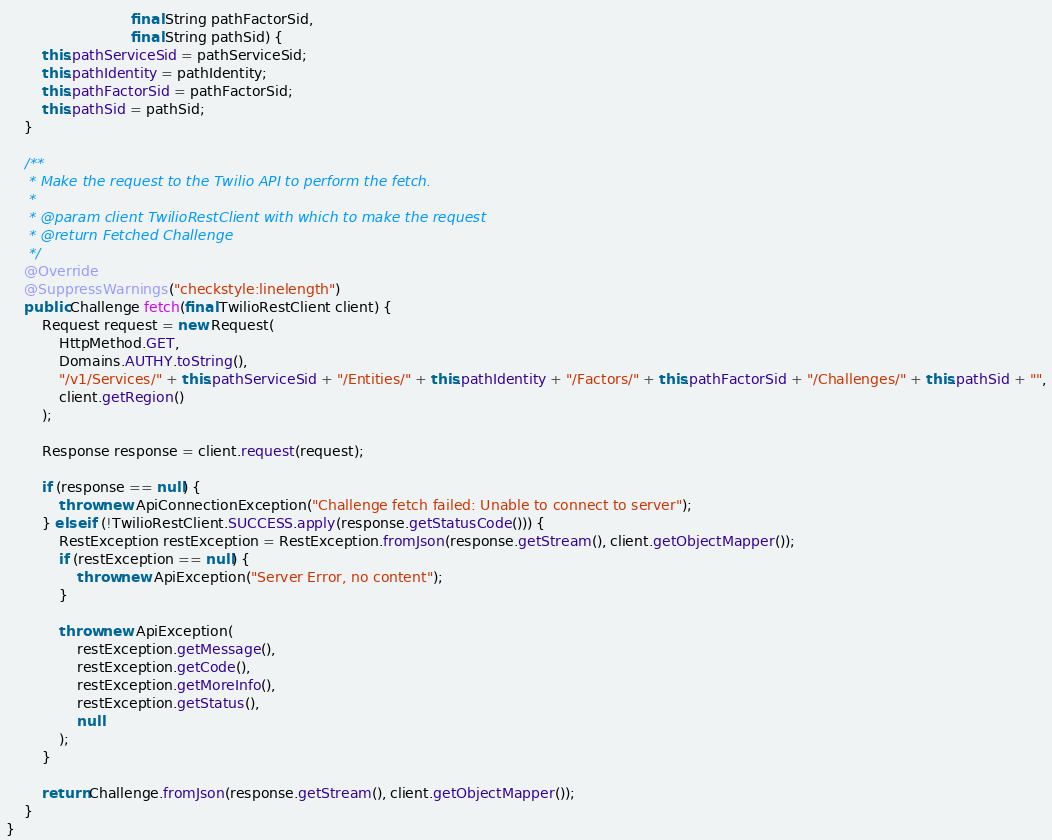<code> <loc_0><loc_0><loc_500><loc_500><_Java_>                            final String pathFactorSid, 
                            final String pathSid) {
        this.pathServiceSid = pathServiceSid;
        this.pathIdentity = pathIdentity;
        this.pathFactorSid = pathFactorSid;
        this.pathSid = pathSid;
    }

    /**
     * Make the request to the Twilio API to perform the fetch.
     * 
     * @param client TwilioRestClient with which to make the request
     * @return Fetched Challenge
     */
    @Override
    @SuppressWarnings("checkstyle:linelength")
    public Challenge fetch(final TwilioRestClient client) {
        Request request = new Request(
            HttpMethod.GET,
            Domains.AUTHY.toString(),
            "/v1/Services/" + this.pathServiceSid + "/Entities/" + this.pathIdentity + "/Factors/" + this.pathFactorSid + "/Challenges/" + this.pathSid + "",
            client.getRegion()
        );

        Response response = client.request(request);

        if (response == null) {
            throw new ApiConnectionException("Challenge fetch failed: Unable to connect to server");
        } else if (!TwilioRestClient.SUCCESS.apply(response.getStatusCode())) {
            RestException restException = RestException.fromJson(response.getStream(), client.getObjectMapper());
            if (restException == null) {
                throw new ApiException("Server Error, no content");
            }

            throw new ApiException(
                restException.getMessage(),
                restException.getCode(),
                restException.getMoreInfo(),
                restException.getStatus(),
                null
            );
        }

        return Challenge.fromJson(response.getStream(), client.getObjectMapper());
    }
}</code> 